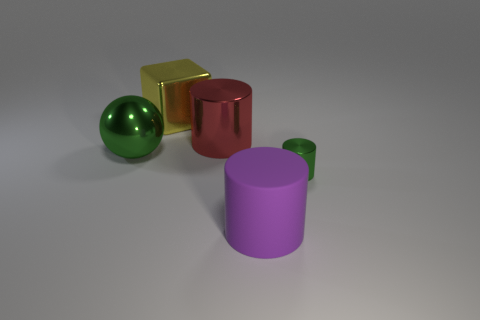Are there any other things that have the same material as the purple cylinder?
Make the answer very short. No. Is there any other thing that has the same size as the green metal cylinder?
Offer a terse response. No. There is a ball that is the same color as the tiny cylinder; what is it made of?
Provide a short and direct response. Metal. There is a block that is the same size as the green metal sphere; what is it made of?
Your answer should be very brief. Metal. Is there a cyan matte cylinder of the same size as the yellow thing?
Offer a terse response. No. What color is the large sphere?
Your answer should be very brief. Green. The large cylinder that is in front of the large metal thing that is on the right side of the shiny block is what color?
Offer a terse response. Purple. There is a object that is in front of the metallic object that is in front of the green metal object behind the small cylinder; what shape is it?
Offer a terse response. Cylinder. What number of cylinders have the same material as the yellow block?
Keep it short and to the point. 2. How many large yellow objects are behind the large cylinder that is behind the large green metallic object?
Make the answer very short. 1. 